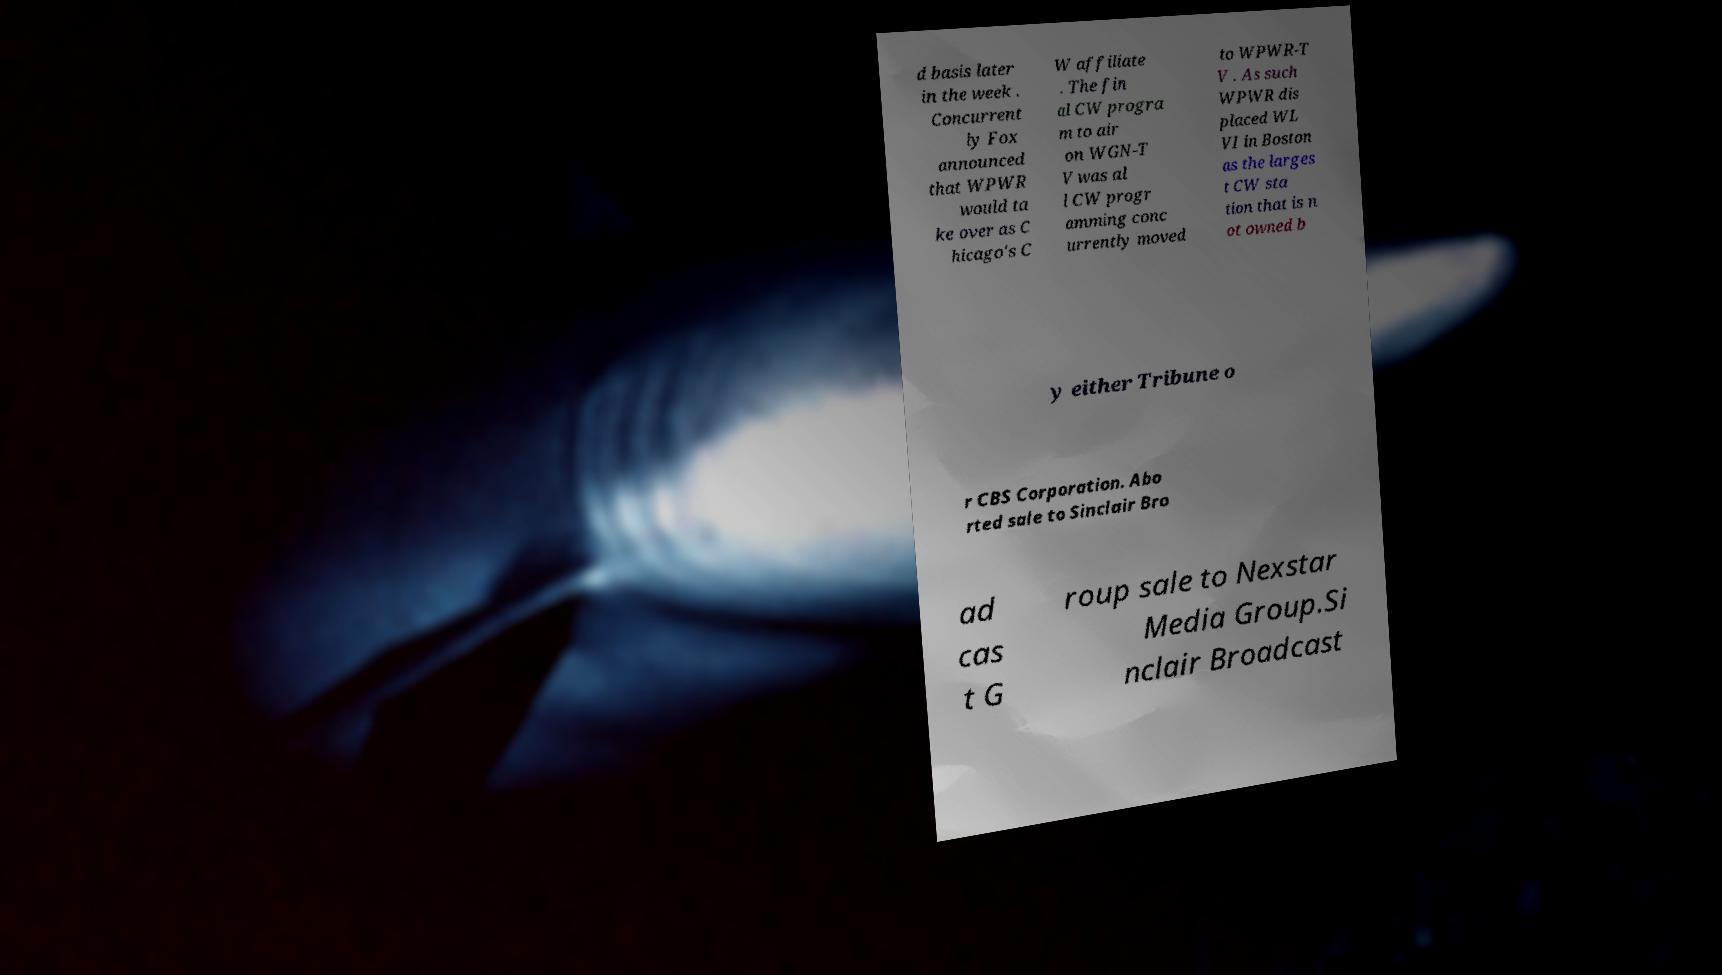What messages or text are displayed in this image? I need them in a readable, typed format. d basis later in the week . Concurrent ly Fox announced that WPWR would ta ke over as C hicago's C W affiliate . The fin al CW progra m to air on WGN-T V was al l CW progr amming conc urrently moved to WPWR-T V . As such WPWR dis placed WL VI in Boston as the larges t CW sta tion that is n ot owned b y either Tribune o r CBS Corporation. Abo rted sale to Sinclair Bro ad cas t G roup sale to Nexstar Media Group.Si nclair Broadcast 